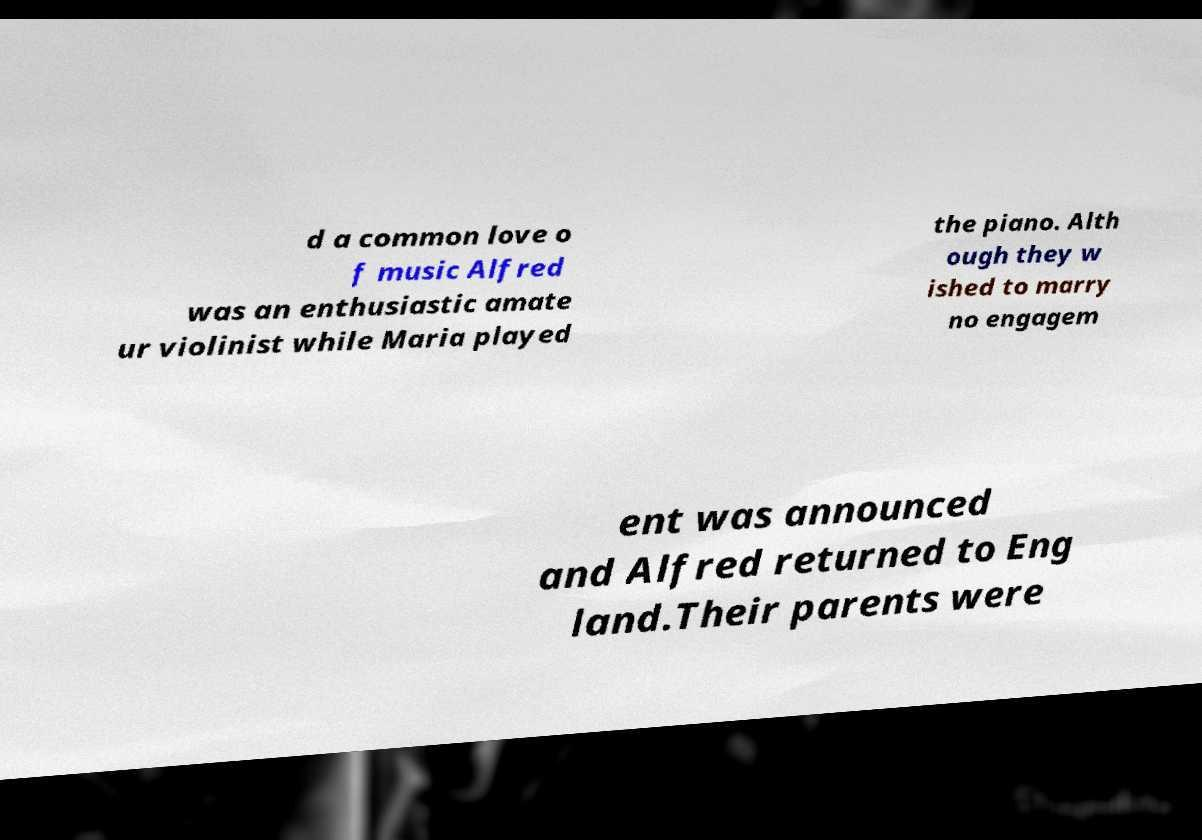Can you read and provide the text displayed in the image?This photo seems to have some interesting text. Can you extract and type it out for me? d a common love o f music Alfred was an enthusiastic amate ur violinist while Maria played the piano. Alth ough they w ished to marry no engagem ent was announced and Alfred returned to Eng land.Their parents were 